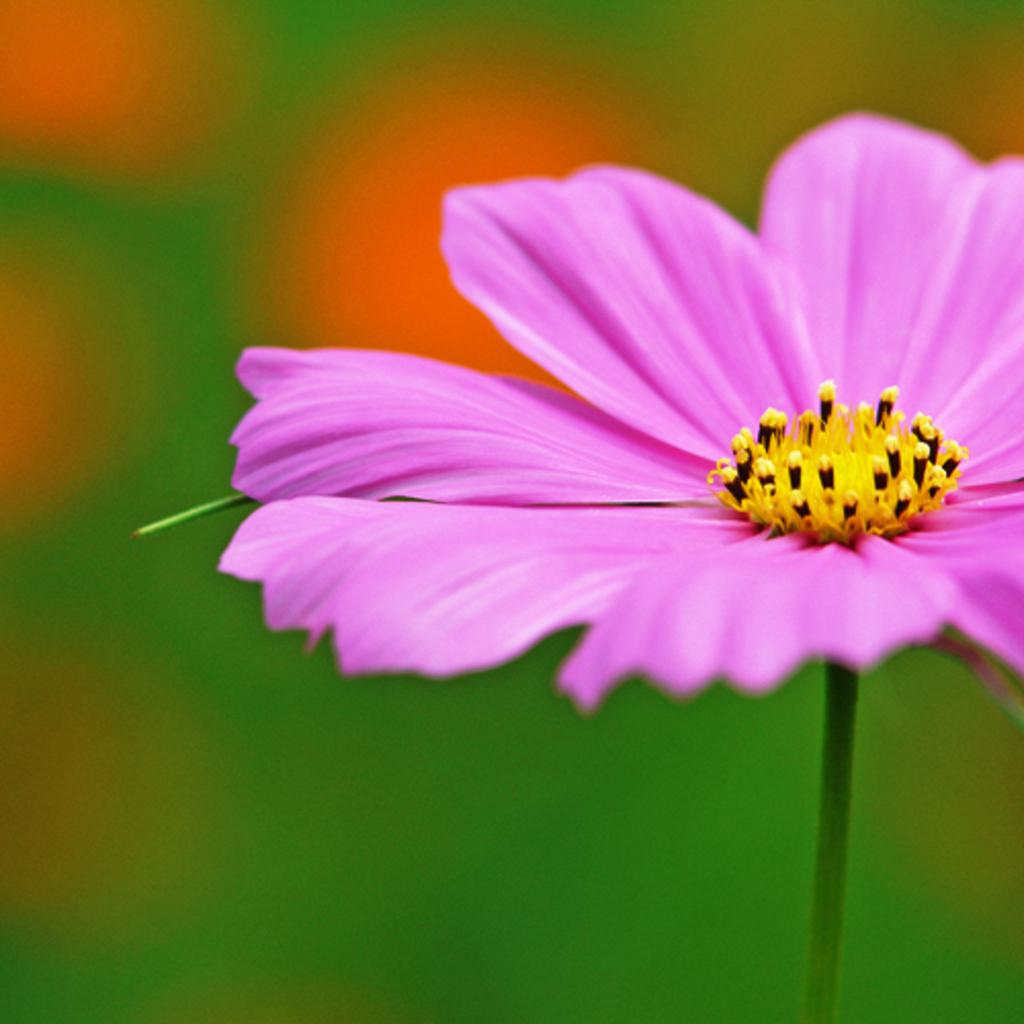What is the main subject of the picture? There is a flower in the picture. Can you describe the background of the image? The background of the image is blurred. What type of coat is the flower wearing in the image? There is no coat present in the image, as flowers do not wear clothing. 